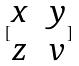Convert formula to latex. <formula><loc_0><loc_0><loc_500><loc_500>[ \begin{matrix} x & y \\ z & v \end{matrix} ]</formula> 